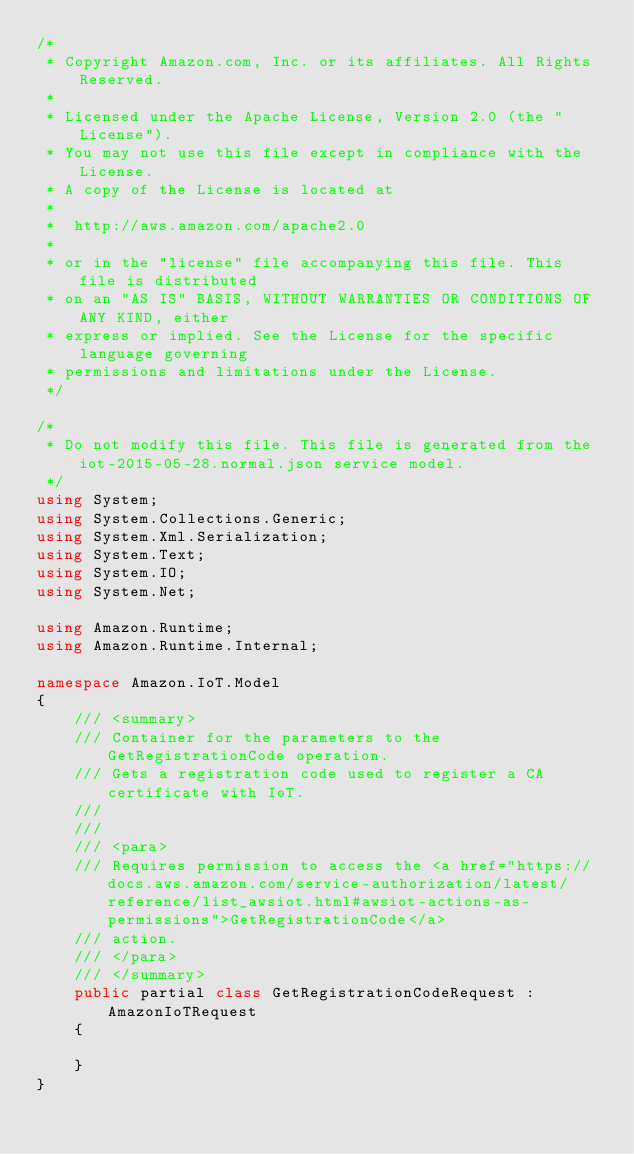<code> <loc_0><loc_0><loc_500><loc_500><_C#_>/*
 * Copyright Amazon.com, Inc. or its affiliates. All Rights Reserved.
 * 
 * Licensed under the Apache License, Version 2.0 (the "License").
 * You may not use this file except in compliance with the License.
 * A copy of the License is located at
 * 
 *  http://aws.amazon.com/apache2.0
 * 
 * or in the "license" file accompanying this file. This file is distributed
 * on an "AS IS" BASIS, WITHOUT WARRANTIES OR CONDITIONS OF ANY KIND, either
 * express or implied. See the License for the specific language governing
 * permissions and limitations under the License.
 */

/*
 * Do not modify this file. This file is generated from the iot-2015-05-28.normal.json service model.
 */
using System;
using System.Collections.Generic;
using System.Xml.Serialization;
using System.Text;
using System.IO;
using System.Net;

using Amazon.Runtime;
using Amazon.Runtime.Internal;

namespace Amazon.IoT.Model
{
    /// <summary>
    /// Container for the parameters to the GetRegistrationCode operation.
    /// Gets a registration code used to register a CA certificate with IoT.
    /// 
    ///  
    /// <para>
    /// Requires permission to access the <a href="https://docs.aws.amazon.com/service-authorization/latest/reference/list_awsiot.html#awsiot-actions-as-permissions">GetRegistrationCode</a>
    /// action.
    /// </para>
    /// </summary>
    public partial class GetRegistrationCodeRequest : AmazonIoTRequest
    {

    }
}</code> 